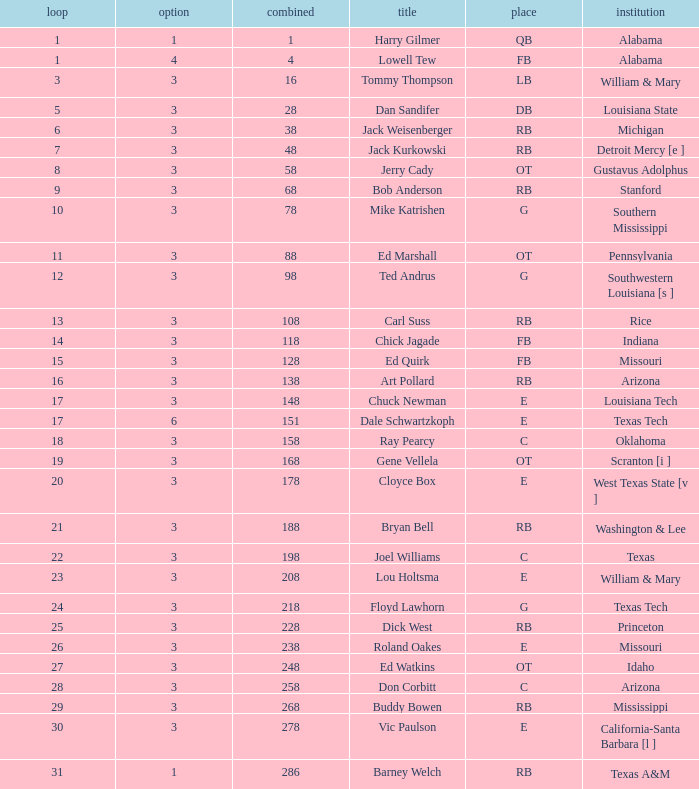How much Overall has a Name of bob anderson? 1.0. 